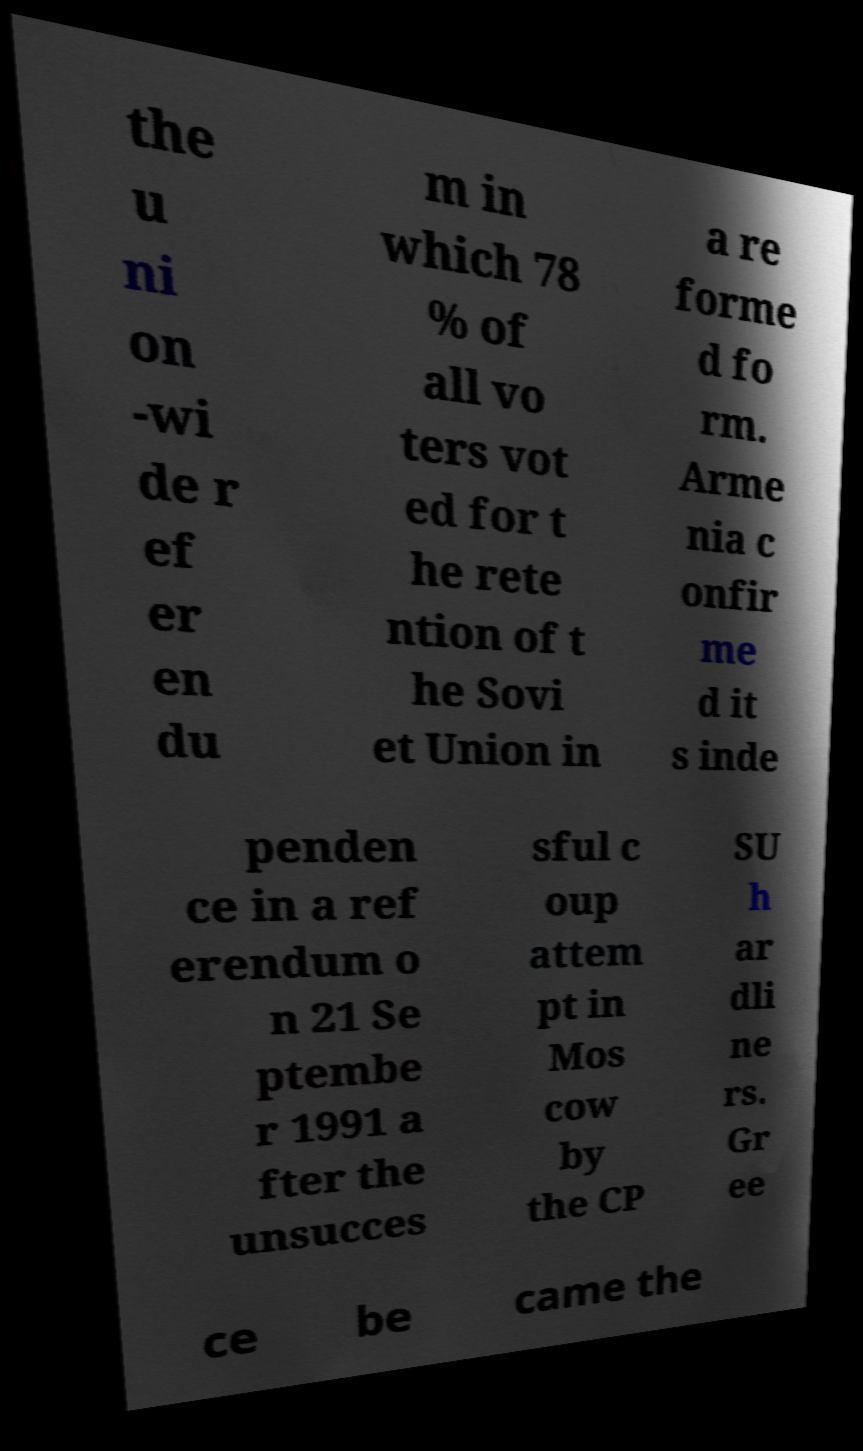There's text embedded in this image that I need extracted. Can you transcribe it verbatim? the u ni on -wi de r ef er en du m in which 78 % of all vo ters vot ed for t he rete ntion of t he Sovi et Union in a re forme d fo rm. Arme nia c onfir me d it s inde penden ce in a ref erendum o n 21 Se ptembe r 1991 a fter the unsucces sful c oup attem pt in Mos cow by the CP SU h ar dli ne rs. Gr ee ce be came the 